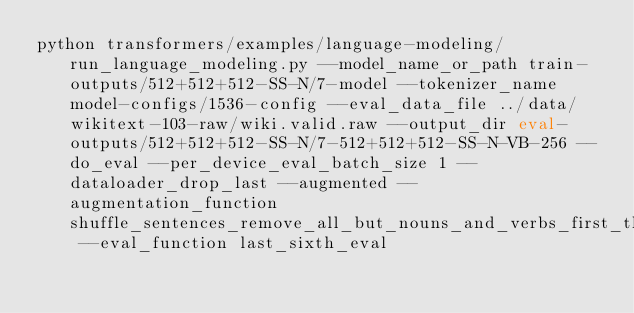<code> <loc_0><loc_0><loc_500><loc_500><_Bash_>python transformers/examples/language-modeling/run_language_modeling.py --model_name_or_path train-outputs/512+512+512-SS-N/7-model --tokenizer_name model-configs/1536-config --eval_data_file ../data/wikitext-103-raw/wiki.valid.raw --output_dir eval-outputs/512+512+512-SS-N/7-512+512+512-SS-N-VB-256 --do_eval --per_device_eval_batch_size 1 --dataloader_drop_last --augmented --augmentation_function shuffle_sentences_remove_all_but_nouns_and_verbs_first_third_sixth --eval_function last_sixth_eval</code> 